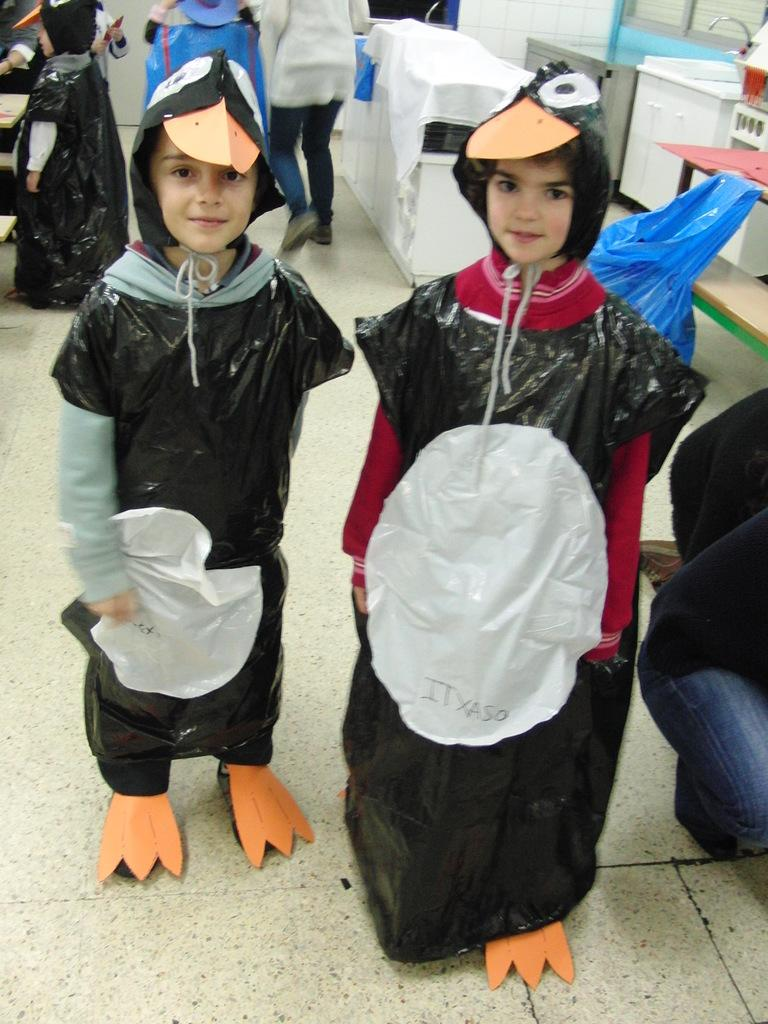What are the children in the image wearing? The children in the image are wearing costumes. How many people are present in the image? There are people in the image, but the exact number is not specified. What can be seen in the background of the image? In the background of the image, there are tables, a sink, a cupboard, a wall, a floor, a plastic cover, and a cloth. What type of surface is the floor made of? The type of floor surface is not specified in the facts. How many cherries are on the table in the image? There is no mention of cherries in the image, so we cannot determine their presence or quantity. Can you describe the air quality in the image? The air quality is not mentioned in the facts, so we cannot determine the air quality in the image. 